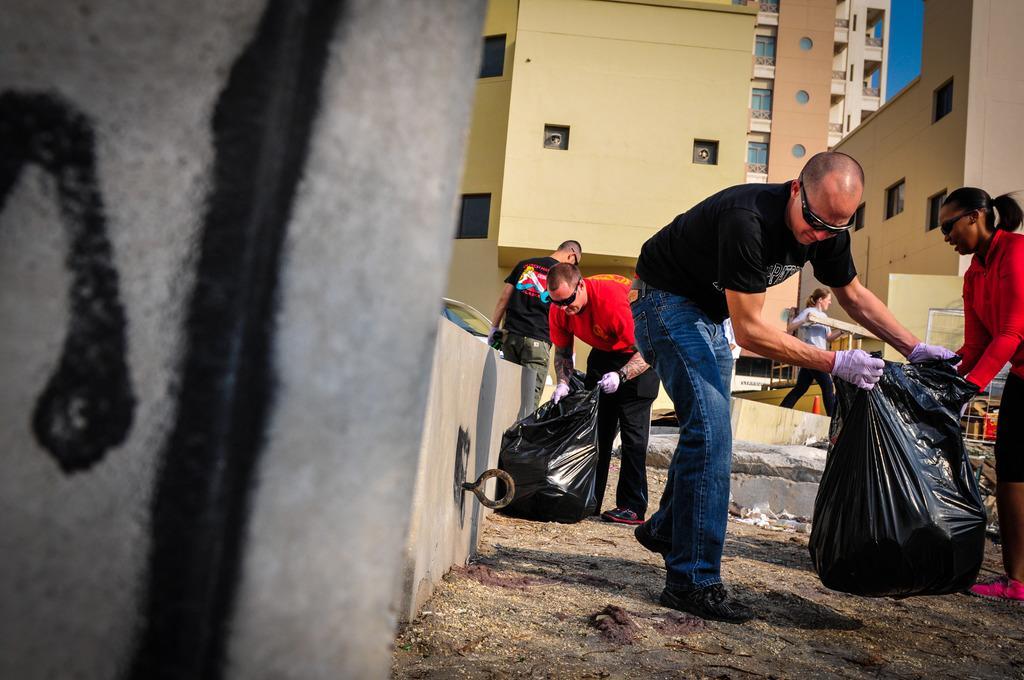Can you describe this image briefly? In this image there are some people who are holding some plastic covers, and they are wearing gloves. At the bottom there is sand and some scrap, and in the background there are buildings, barricades and some other objects. On the left side of the image there is a wall. 